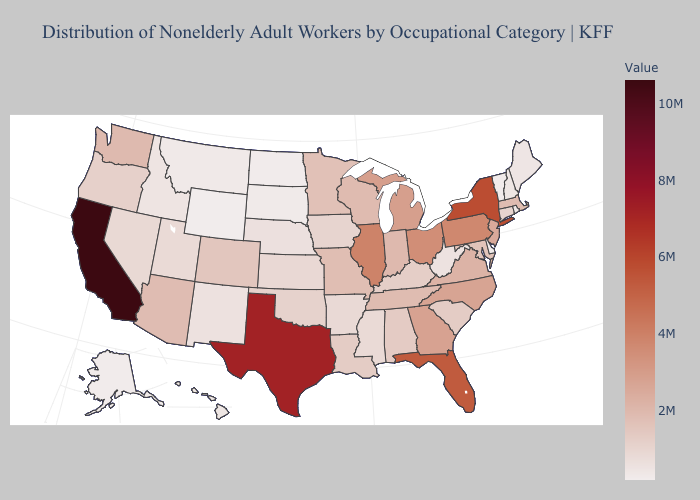Does Massachusetts have the lowest value in the Northeast?
Keep it brief. No. Among the states that border Montana , does South Dakota have the highest value?
Keep it brief. No. Among the states that border Illinois , which have the highest value?
Be succinct. Indiana. Among the states that border South Carolina , does North Carolina have the highest value?
Write a very short answer. No. Which states have the highest value in the USA?
Be succinct. California. Does California have the highest value in the USA?
Quick response, please. Yes. 